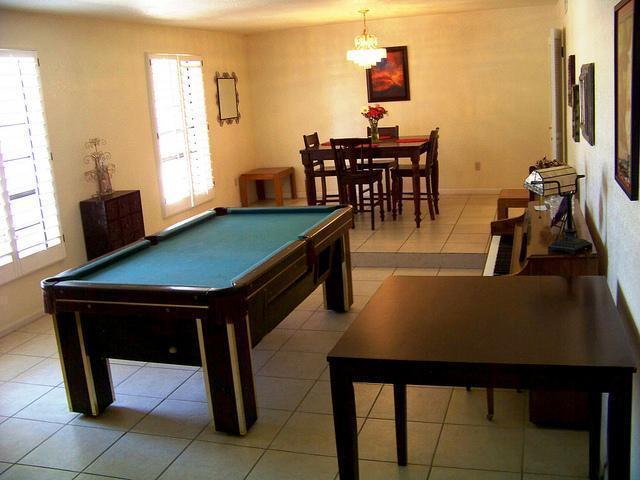What kind of room is this one?
Answer the question by selecting the correct answer among the 4 following choices.
Options: Dining room, music room, karaoke room, recreation room. Recreation room. 